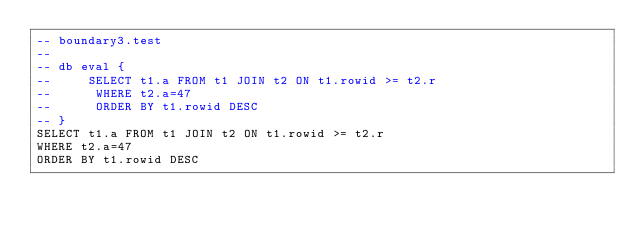<code> <loc_0><loc_0><loc_500><loc_500><_SQL_>-- boundary3.test
-- 
-- db eval {
--     SELECT t1.a FROM t1 JOIN t2 ON t1.rowid >= t2.r
--      WHERE t2.a=47
--      ORDER BY t1.rowid DESC
-- }
SELECT t1.a FROM t1 JOIN t2 ON t1.rowid >= t2.r
WHERE t2.a=47
ORDER BY t1.rowid DESC</code> 